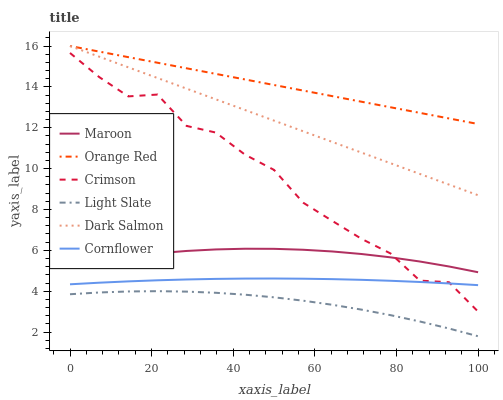Does Light Slate have the minimum area under the curve?
Answer yes or no. Yes. Does Orange Red have the maximum area under the curve?
Answer yes or no. Yes. Does Dark Salmon have the minimum area under the curve?
Answer yes or no. No. Does Dark Salmon have the maximum area under the curve?
Answer yes or no. No. Is Orange Red the smoothest?
Answer yes or no. Yes. Is Crimson the roughest?
Answer yes or no. Yes. Is Light Slate the smoothest?
Answer yes or no. No. Is Light Slate the roughest?
Answer yes or no. No. Does Dark Salmon have the lowest value?
Answer yes or no. No. Does Orange Red have the highest value?
Answer yes or no. Yes. Does Light Slate have the highest value?
Answer yes or no. No. Is Maroon less than Orange Red?
Answer yes or no. Yes. Is Cornflower greater than Light Slate?
Answer yes or no. Yes. Does Orange Red intersect Dark Salmon?
Answer yes or no. Yes. Is Orange Red less than Dark Salmon?
Answer yes or no. No. Is Orange Red greater than Dark Salmon?
Answer yes or no. No. Does Maroon intersect Orange Red?
Answer yes or no. No. 